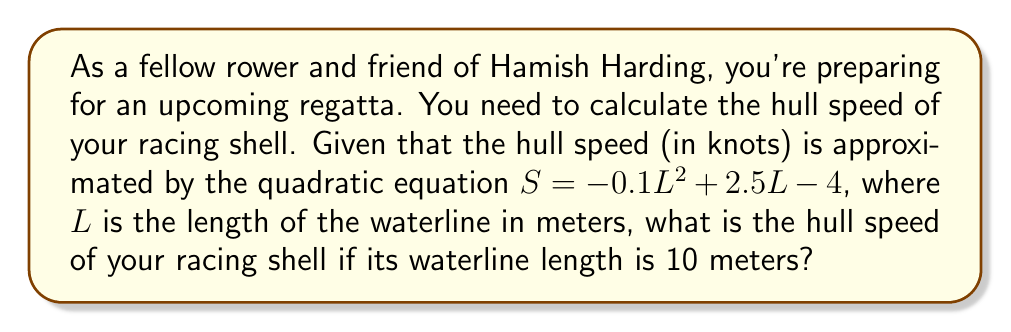Provide a solution to this math problem. To solve this problem, we need to follow these steps:

1. Identify the given quadratic equation:
   $S = -0.1L^2 + 2.5L - 4$

2. Substitute the given waterline length (L = 10 meters) into the equation:
   $S = -0.1(10)^2 + 2.5(10) - 4$

3. Simplify the equation:
   $S = -0.1(100) + 25 - 4$
   $S = -10 + 25 - 4$

4. Perform the arithmetic:
   $S = 11$

Therefore, the hull speed of the racing shell with a waterline length of 10 meters is 11 knots.
Answer: 11 knots 